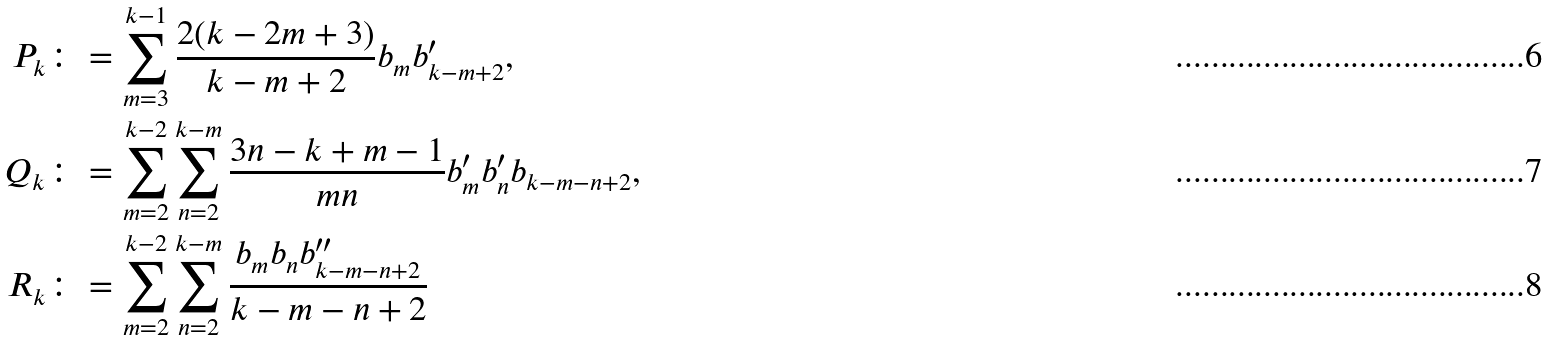<formula> <loc_0><loc_0><loc_500><loc_500>P _ { k } & \colon = \sum _ { m = 3 } ^ { k - 1 } \frac { 2 ( k - 2 m + 3 ) } { k - m + 2 } b _ { m } b ^ { \prime } _ { k - m + 2 } , \\ Q _ { k } & \colon = \sum _ { m = 2 } ^ { k - 2 } \sum _ { n = 2 } ^ { k - m } \frac { 3 n - k + m - 1 } { m n } b ^ { \prime } _ { m } b ^ { \prime } _ { n } b _ { k - m - n + 2 } , \\ R _ { k } & \colon = \sum _ { m = 2 } ^ { k - 2 } \sum _ { n = 2 } ^ { k - m } \frac { b _ { m } b _ { n } b ^ { \prime \prime } _ { k - m - n + 2 } } { k - m - n + 2 }</formula> 